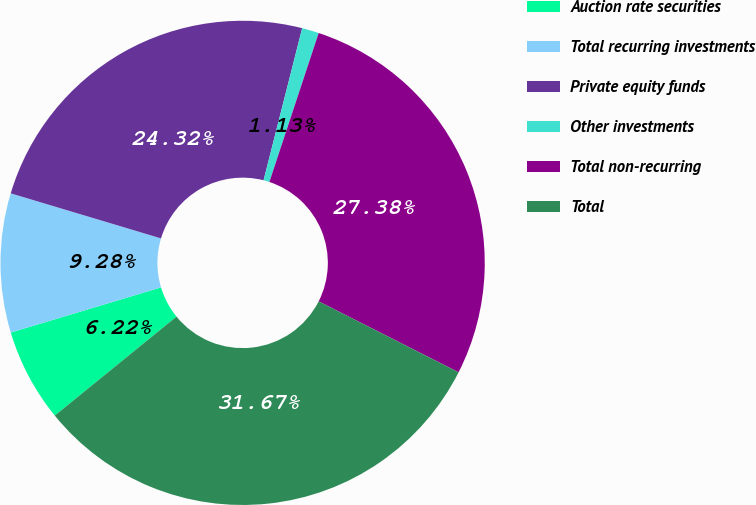<chart> <loc_0><loc_0><loc_500><loc_500><pie_chart><fcel>Auction rate securities<fcel>Total recurring investments<fcel>Private equity funds<fcel>Other investments<fcel>Total non-recurring<fcel>Total<nl><fcel>6.22%<fcel>9.28%<fcel>24.32%<fcel>1.13%<fcel>27.38%<fcel>31.67%<nl></chart> 